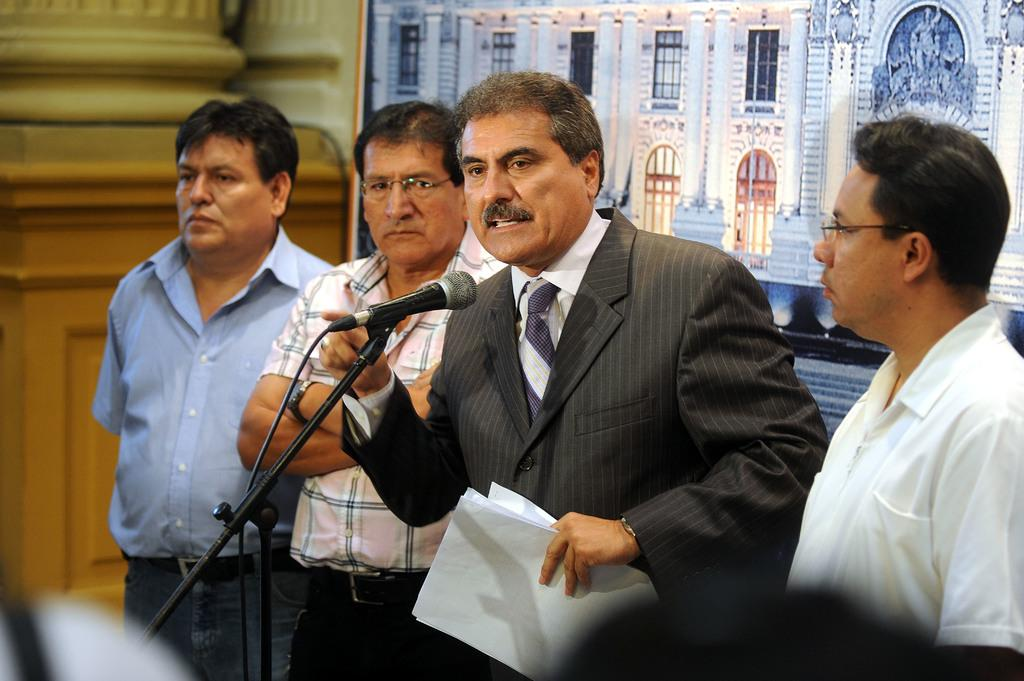What is happening in the image involving the people? There are people standing in the image, and a man is holding papers and talking. What object is in front of the man who is talking? There is a microphone with a stand in front of the man. What can be seen in the background of the image? There is a banner visible in the background of the image. How many sisters are standing next to the man with the microphone? There is no mention of sisters in the image, and no indication of their presence. 